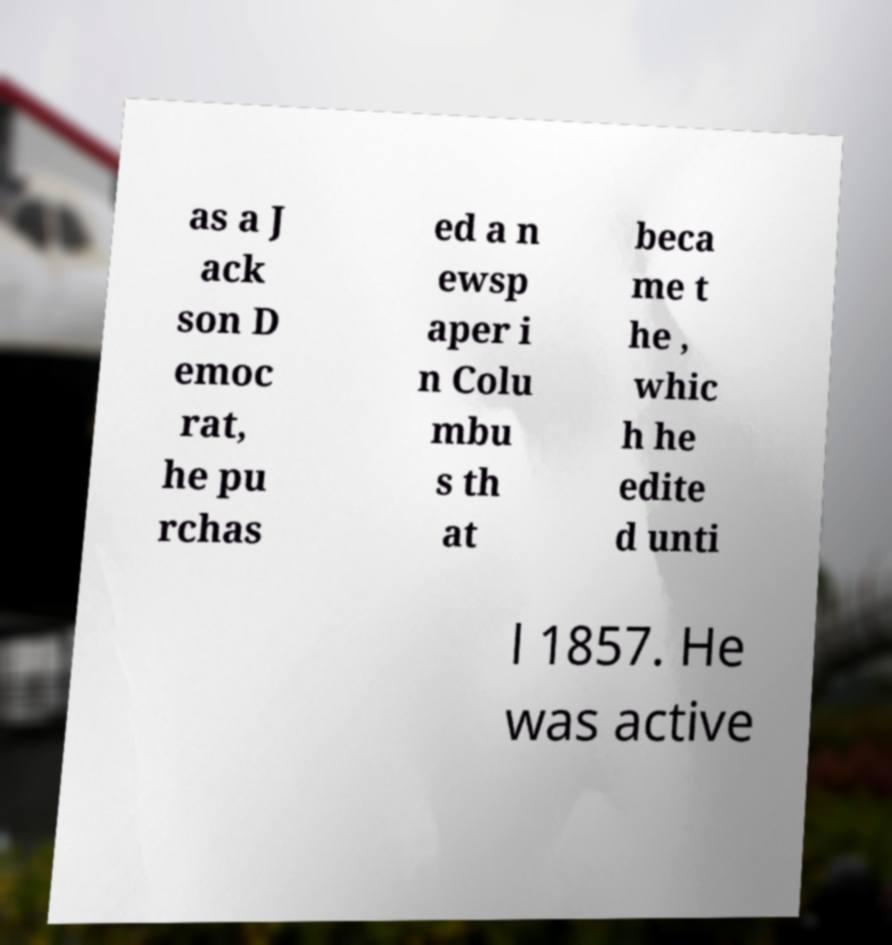There's text embedded in this image that I need extracted. Can you transcribe it verbatim? as a J ack son D emoc rat, he pu rchas ed a n ewsp aper i n Colu mbu s th at beca me t he , whic h he edite d unti l 1857. He was active 